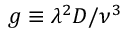Convert formula to latex. <formula><loc_0><loc_0><loc_500><loc_500>g \equiv \lambda ^ { 2 } D / \nu ^ { 3 }</formula> 